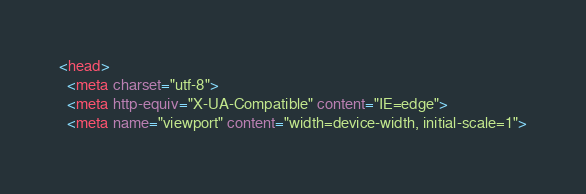<code> <loc_0><loc_0><loc_500><loc_500><_HTML_><head>
  <meta charset="utf-8">
  <meta http-equiv="X-UA-Compatible" content="IE=edge">
  <meta name="viewport" content="width=device-width, initial-scale=1">
</code> 